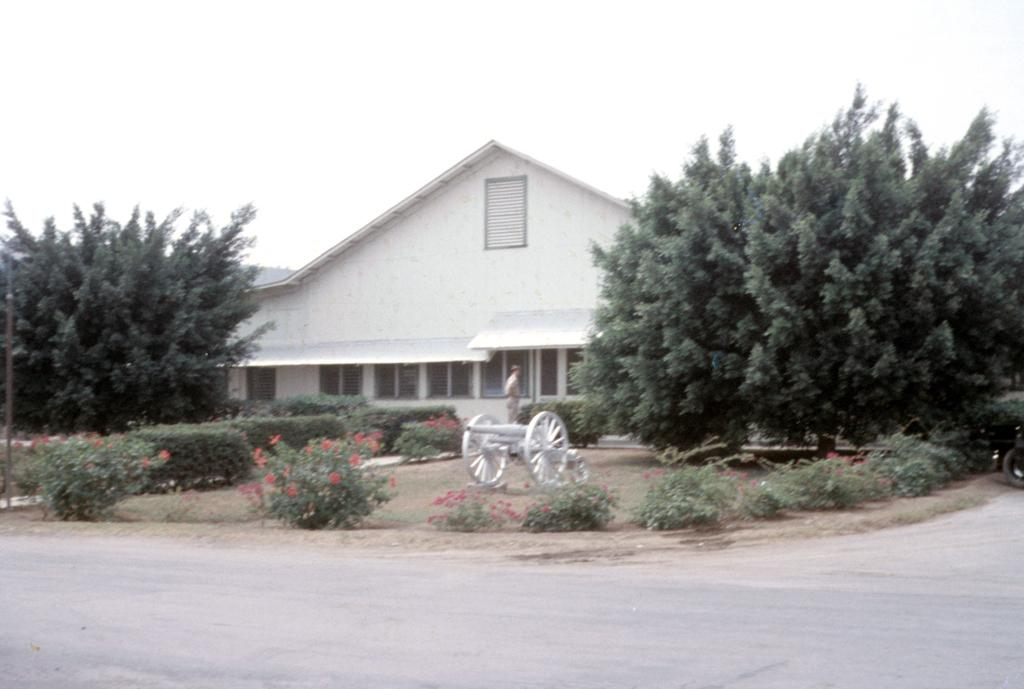What type of vegetation can be seen in the image? There are trees and plants in the image. What type of structure is present in the image? There is a shed in the image. What type of transportation is visible in the image? There is a vehicle in the image. Who or what is present in the image? There is a person standing in the image. What is at the bottom of the image? There is a road at the bottom of the image. What type of pizzas are being protested by the person in the image? There are no pizzas or protest present in the image. What type of pleasure can be seen on the person's face in the image? There is no indication of the person's emotions or pleasure in the image. 